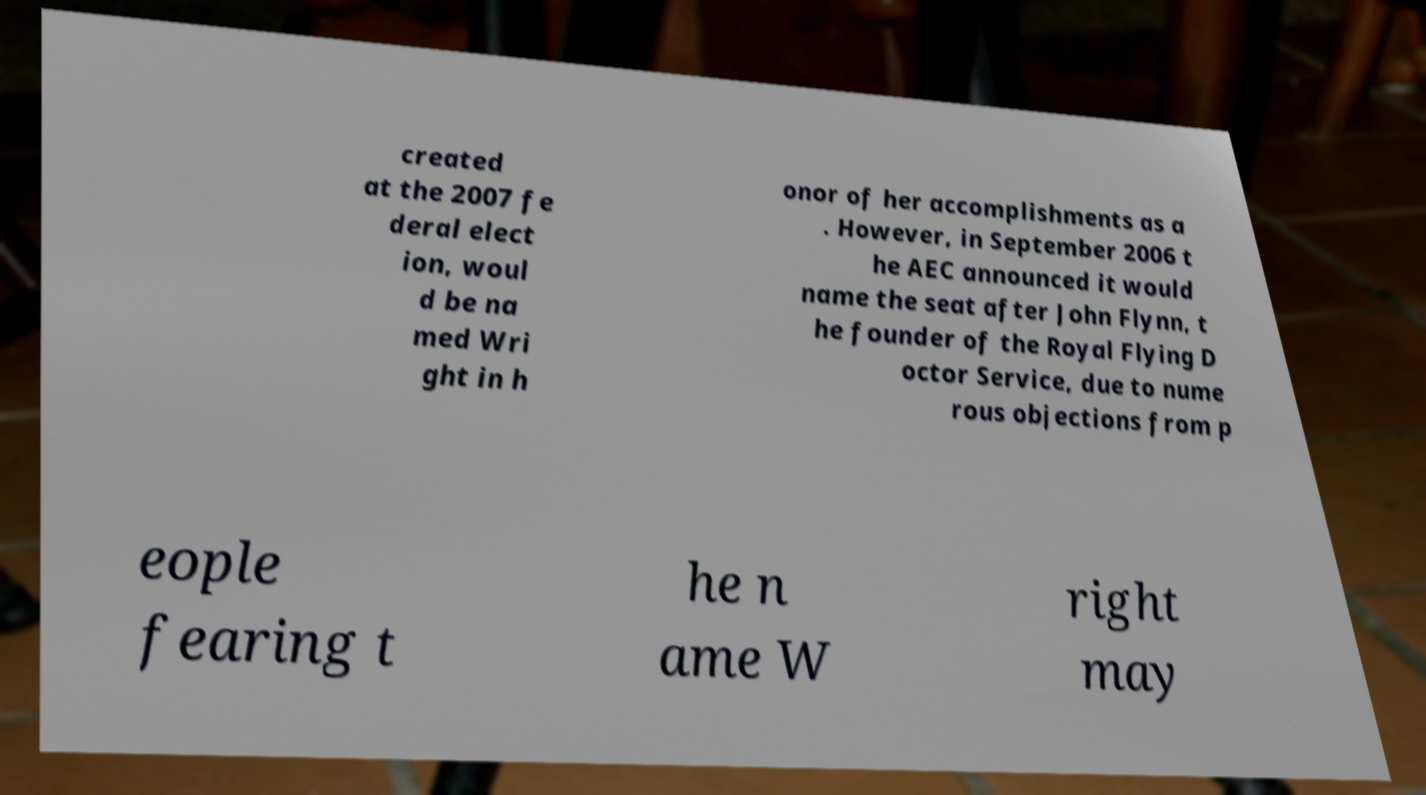Please identify and transcribe the text found in this image. created at the 2007 fe deral elect ion, woul d be na med Wri ght in h onor of her accomplishments as a . However, in September 2006 t he AEC announced it would name the seat after John Flynn, t he founder of the Royal Flying D octor Service, due to nume rous objections from p eople fearing t he n ame W right may 